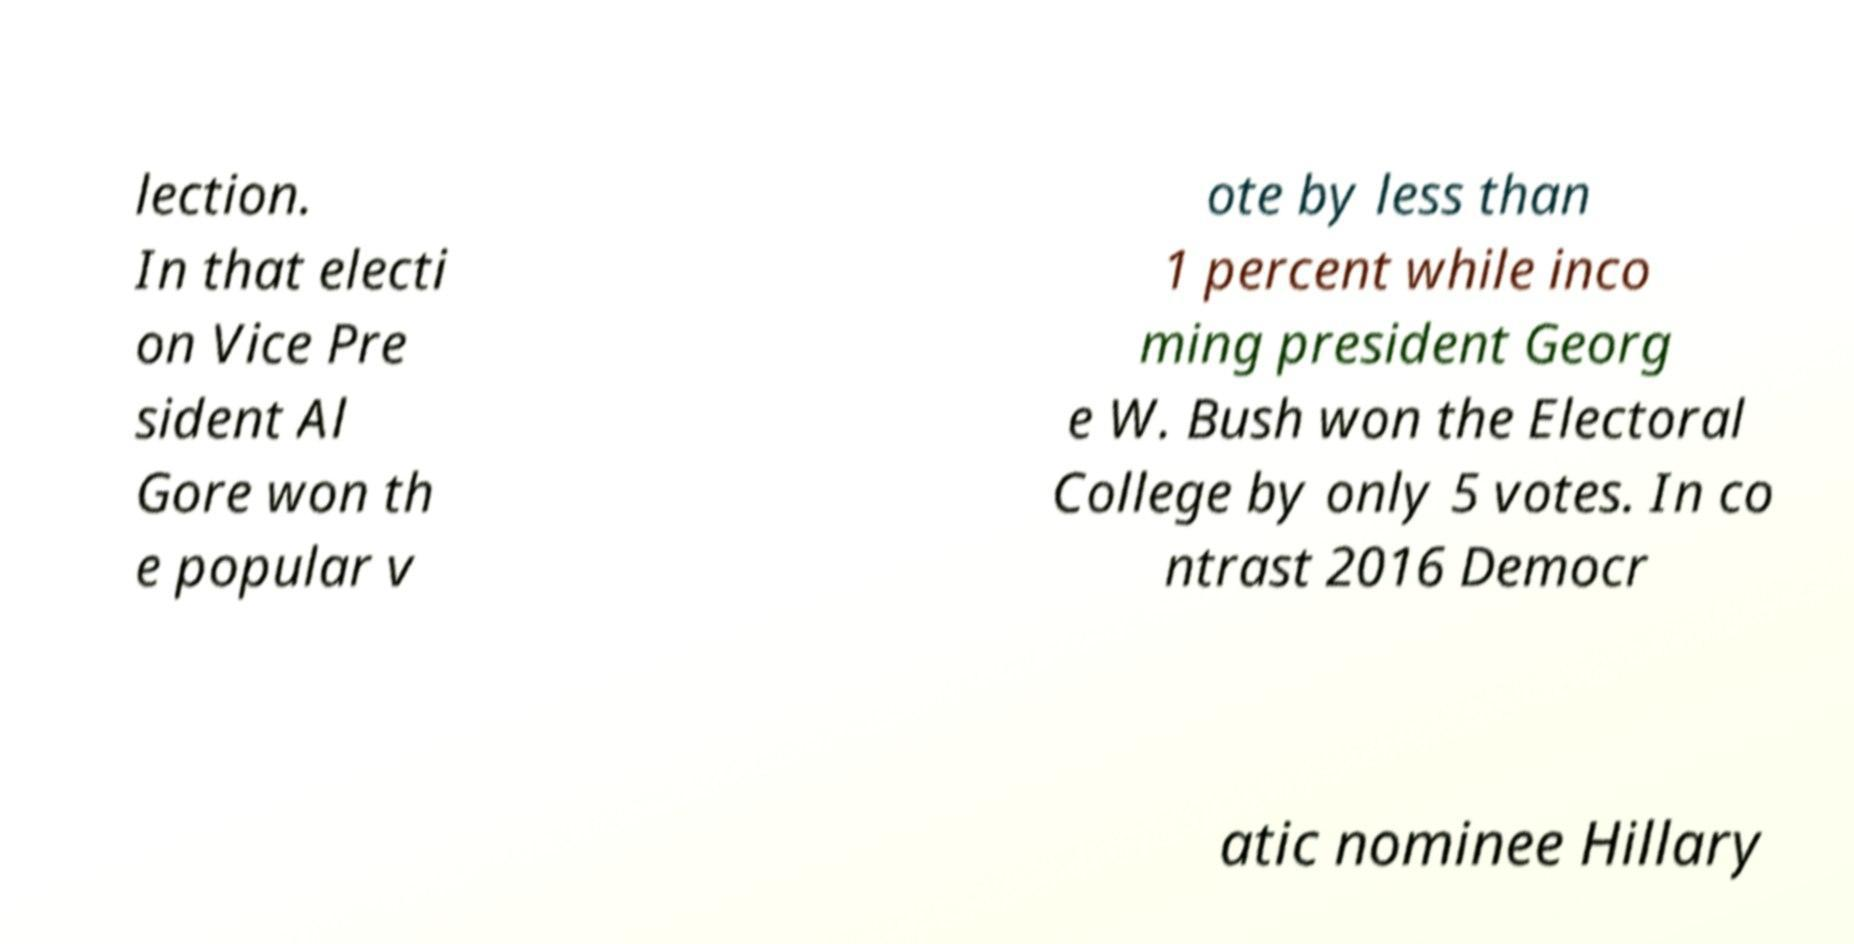For documentation purposes, I need the text within this image transcribed. Could you provide that? lection. In that electi on Vice Pre sident Al Gore won th e popular v ote by less than 1 percent while inco ming president Georg e W. Bush won the Electoral College by only 5 votes. In co ntrast 2016 Democr atic nominee Hillary 